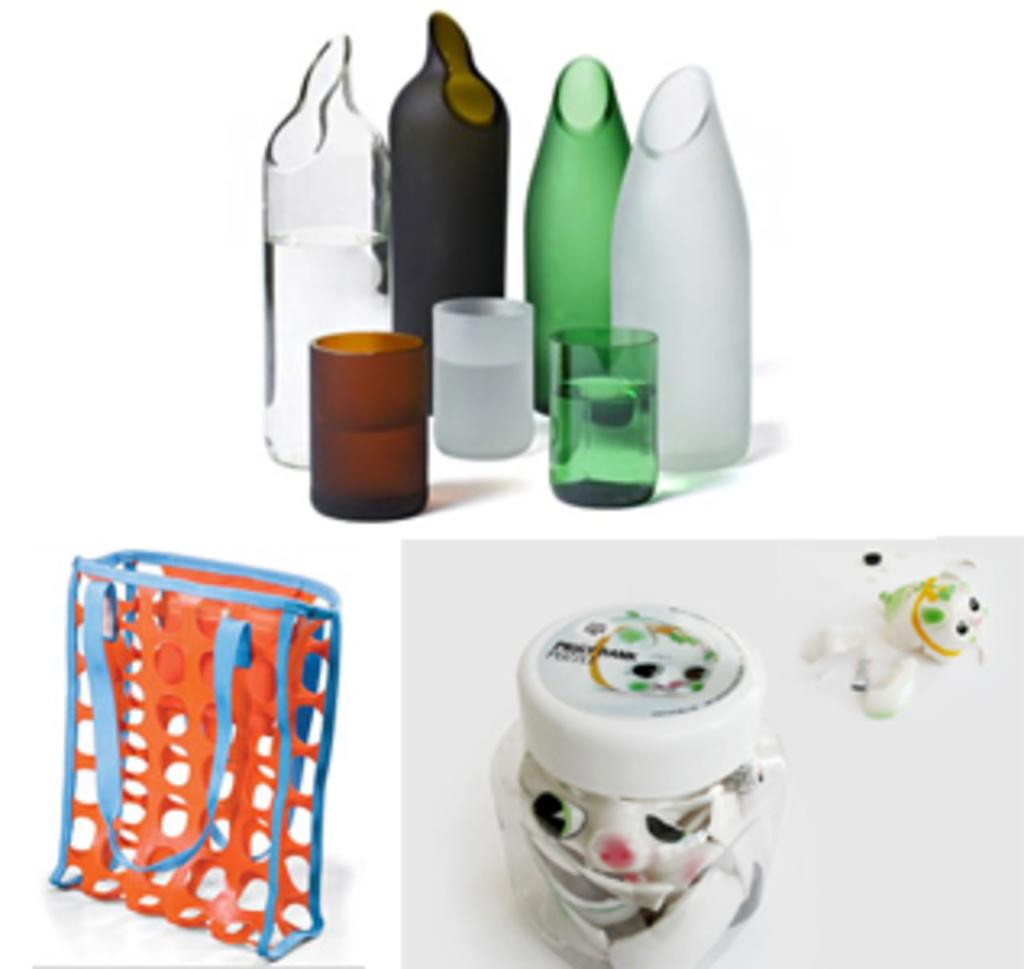What type of containers are visible in the image? There are glass bottles and glasses in the image. What other objects can be seen in the image? There is a bag and a box in the image. How many pies are stacked on top of the cup in the image? There are no pies or cups present in the image. What type of hydrant is visible in the image? There is no hydrant present in the image. 